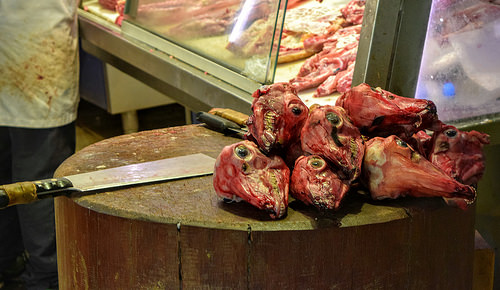<image>
Is the knife next to the head? Yes. The knife is positioned adjacent to the head, located nearby in the same general area. 